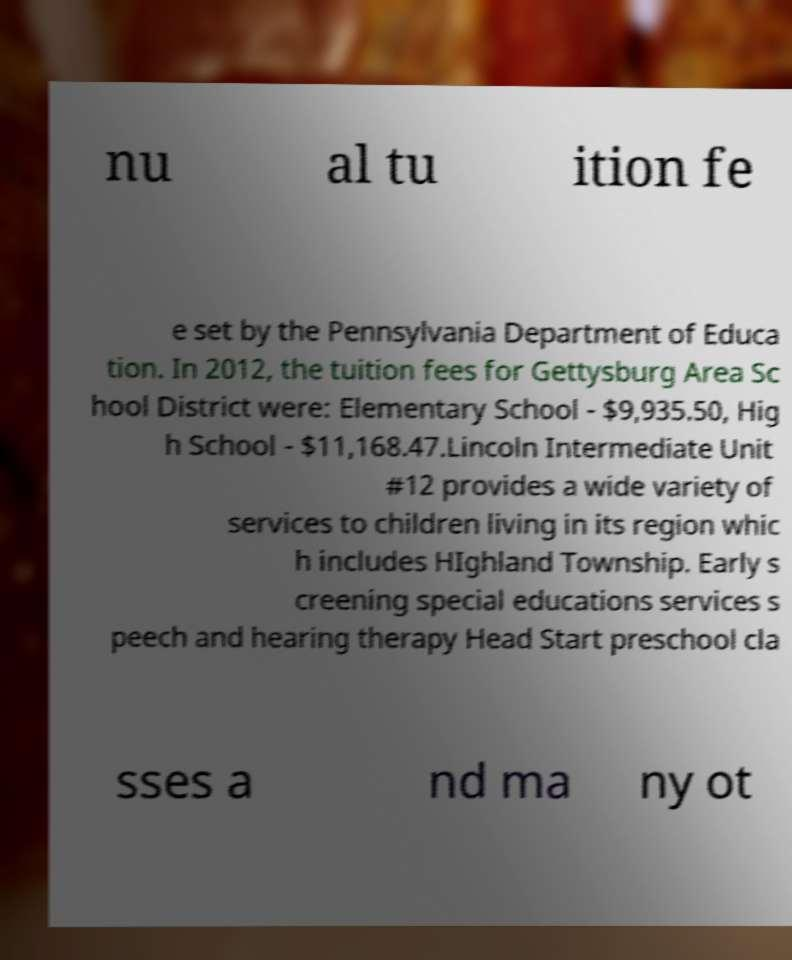Can you read and provide the text displayed in the image?This photo seems to have some interesting text. Can you extract and type it out for me? nu al tu ition fe e set by the Pennsylvania Department of Educa tion. In 2012, the tuition fees for Gettysburg Area Sc hool District were: Elementary School - $9,935.50, Hig h School - $11,168.47.Lincoln Intermediate Unit #12 provides a wide variety of services to children living in its region whic h includes HIghland Township. Early s creening special educations services s peech and hearing therapy Head Start preschool cla sses a nd ma ny ot 